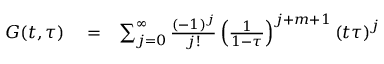<formula> <loc_0><loc_0><loc_500><loc_500>\begin{array} { r l r } { G ( t , \tau ) } & = } & { \sum _ { j = 0 } ^ { \infty } \frac { ( - 1 ) ^ { j } } { j ! } \left ( \frac { 1 } { 1 - \tau } \right ) ^ { j + m + 1 } \left ( t \tau \right ) ^ { j } } \end{array}</formula> 